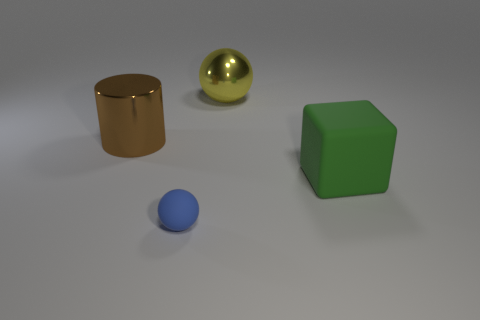There is a sphere that is in front of the yellow ball; what is its size?
Offer a terse response. Small. What material is the brown thing that is the same size as the yellow shiny sphere?
Offer a very short reply. Metal. Is the number of big blue rubber cylinders greater than the number of big yellow shiny spheres?
Your answer should be compact. No. There is a sphere that is on the right side of the sphere that is in front of the large yellow shiny ball; how big is it?
Offer a very short reply. Large. What shape is the brown object that is the same size as the green thing?
Make the answer very short. Cylinder. What shape is the rubber thing on the left side of the thing that is right of the large metal thing that is behind the cylinder?
Make the answer very short. Sphere. What number of big blue cylinders are there?
Offer a terse response. 0. Are there any metal things behind the big cylinder?
Your response must be concise. Yes. Is the big brown thing behind the large matte block made of the same material as the thing to the right of the big metallic sphere?
Your answer should be compact. No. Is the number of small things that are behind the big sphere less than the number of tiny green rubber cylinders?
Keep it short and to the point. No. 